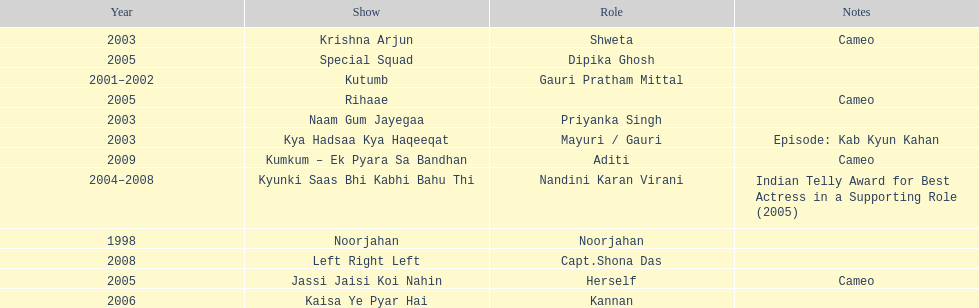The show above left right left Kaisa Ye Pyar Hai. 